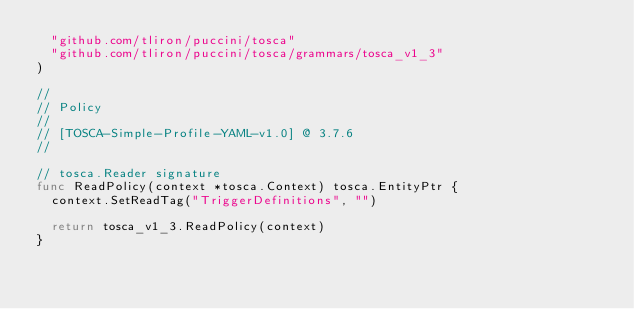Convert code to text. <code><loc_0><loc_0><loc_500><loc_500><_Go_>	"github.com/tliron/puccini/tosca"
	"github.com/tliron/puccini/tosca/grammars/tosca_v1_3"
)

//
// Policy
//
// [TOSCA-Simple-Profile-YAML-v1.0] @ 3.7.6
//

// tosca.Reader signature
func ReadPolicy(context *tosca.Context) tosca.EntityPtr {
	context.SetReadTag("TriggerDefinitions", "")

	return tosca_v1_3.ReadPolicy(context)
}
</code> 